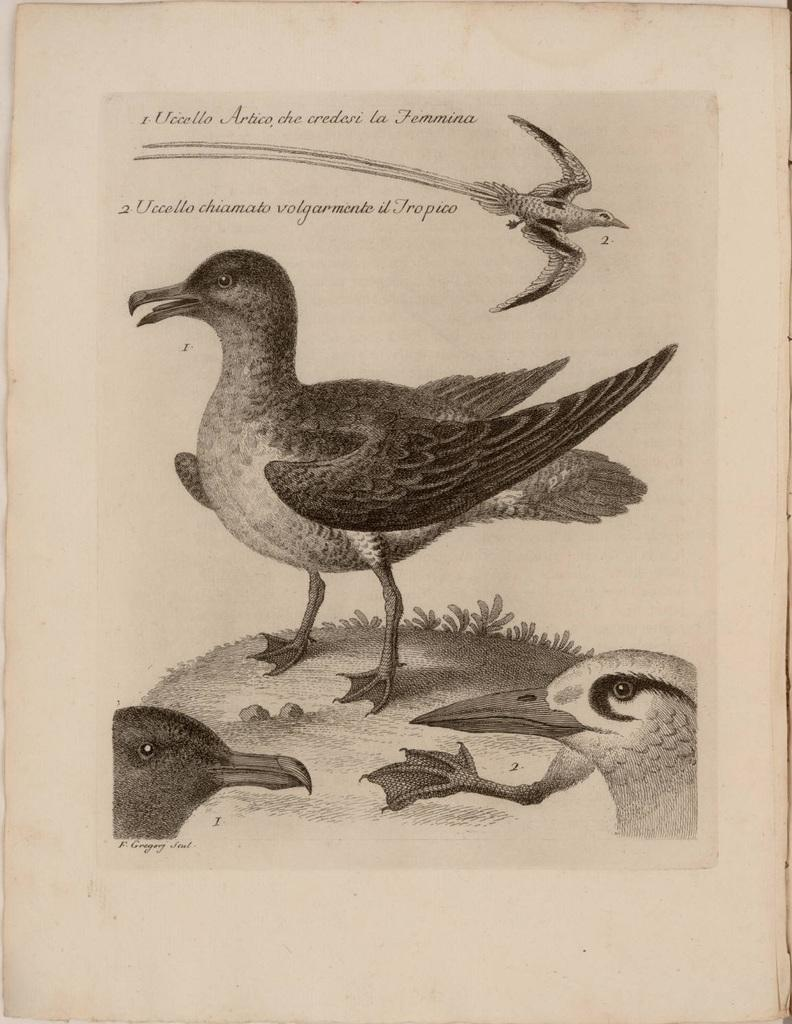What is the main subject of the paper in the image? The main subject of the paper in the image is birds, both on the ground and flying. Can you describe the birds depicted on the paper? There are birds on the ground and a bird flying depicted on the paper. Is there any text visible in the image? Yes, there is text visible in the image. How does the organization of the paper affect the design of the birds depicted on it? The organization of the paper does not affect the design of the birds depicted on it, as the paper is a separate element from the illustration. Can you tell me how many hours the birds on the paper have slept? The birds depicted on the paper are not real, so it is impossible to determine how many hours they have slept. 